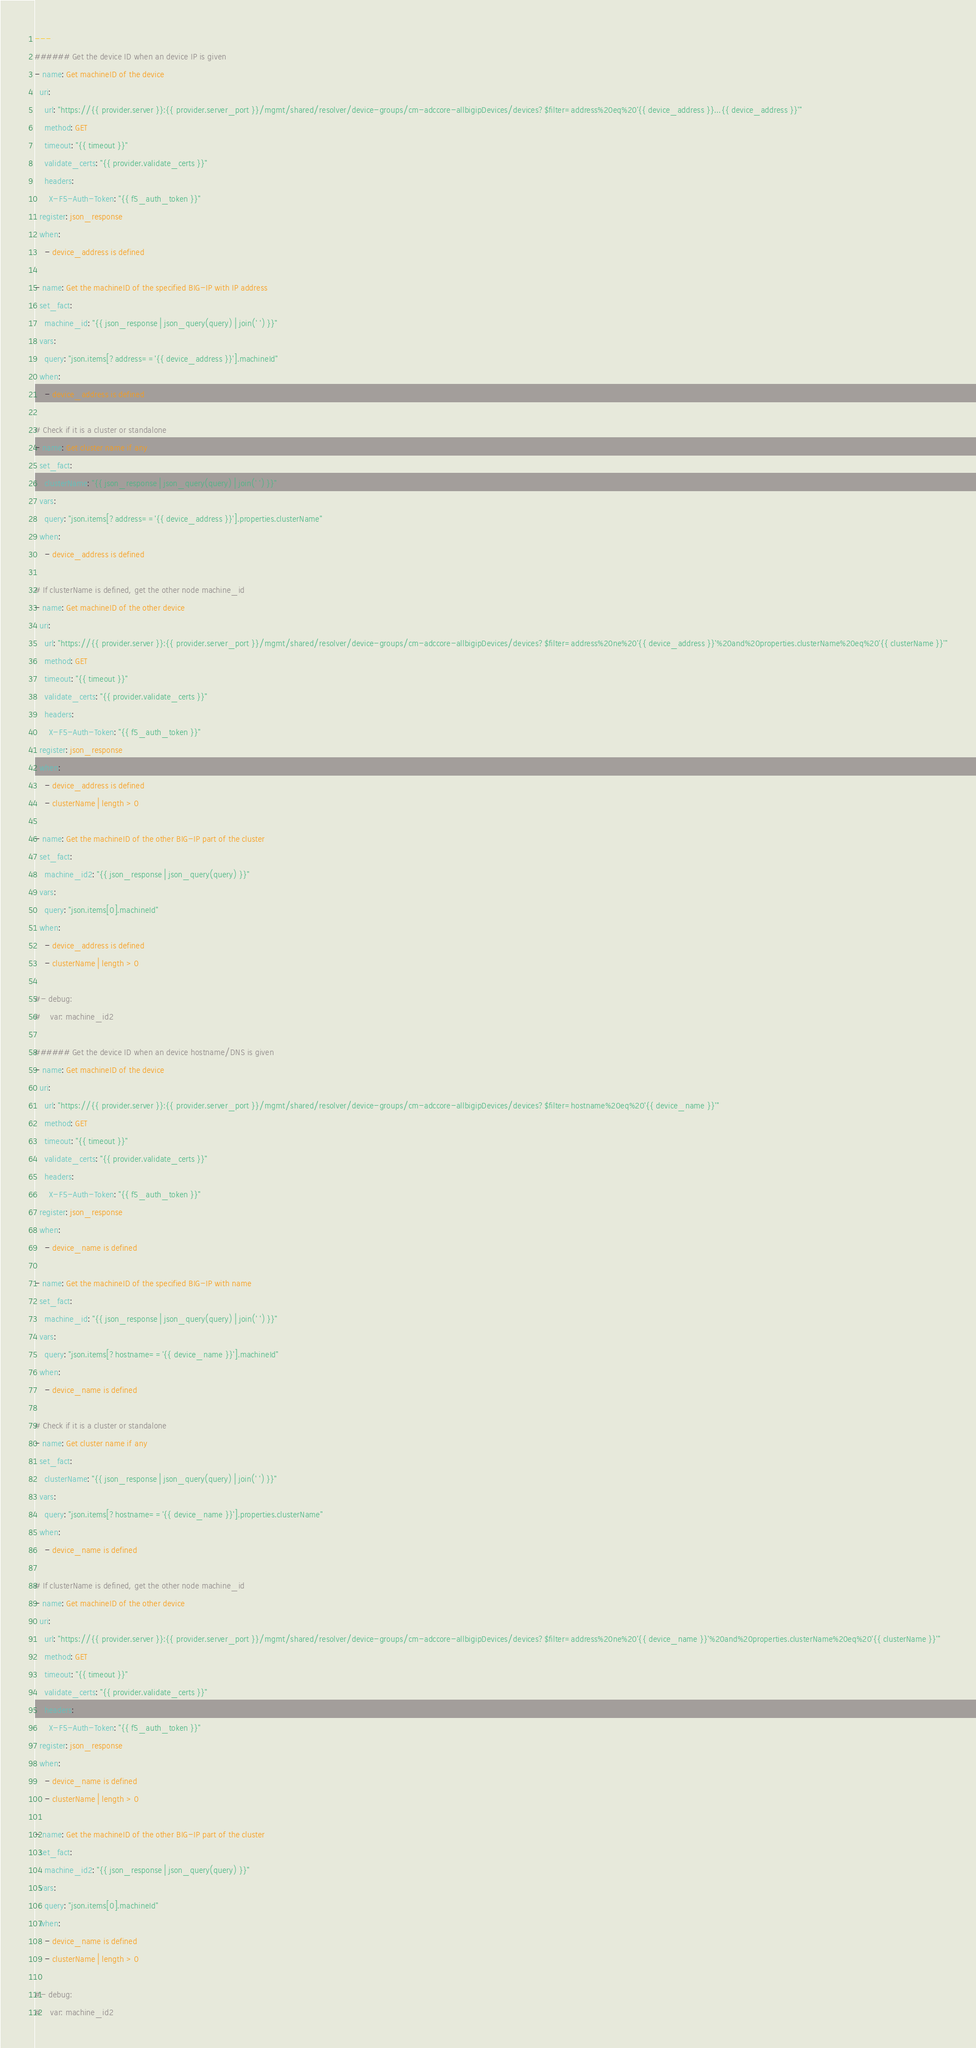<code> <loc_0><loc_0><loc_500><loc_500><_YAML_>---
###### Get the device ID when an device IP is given
- name: Get machineID of the device
  uri:
    url: "https://{{ provider.server }}:{{ provider.server_port }}/mgmt/shared/resolver/device-groups/cm-adccore-allbigipDevices/devices?$filter=address%20eq%20'{{ device_address }}...{{ device_address }}'"
    method: GET
    timeout: "{{ timeout }}"
    validate_certs: "{{ provider.validate_certs }}"
    headers:
      X-F5-Auth-Token: "{{ f5_auth_token }}"
  register: json_response
  when: 
    - device_address is defined

- name: Get the machineID of the specified BIG-IP with IP address
  set_fact:
    machine_id: "{{ json_response | json_query(query) | join(' ') }}"
  vars: 
    query: "json.items[?address=='{{ device_address }}'].machineId"
  when: 
    - device_address is defined

# Check if it is a cluster or standalone
- name: Get cluster name if any
  set_fact:
    clusterName: "{{ json_response | json_query(query) | join(' ') }}"
  vars: 
    query: "json.items[?address=='{{ device_address }}'].properties.clusterName"
  when: 
    - device_address is defined

# If clusterName is defined, get the other node machine_id
- name: Get machineID of the other device
  uri:
    url: "https://{{ provider.server }}:{{ provider.server_port }}/mgmt/shared/resolver/device-groups/cm-adccore-allbigipDevices/devices?$filter=address%20ne%20'{{ device_address }}'%20and%20properties.clusterName%20eq%20'{{ clusterName }}'"
    method: GET
    timeout: "{{ timeout }}"
    validate_certs: "{{ provider.validate_certs }}"
    headers:
      X-F5-Auth-Token: "{{ f5_auth_token }}"
  register: json_response
  when: 
    - device_address is defined
    - clusterName | length > 0
    
- name: Get the machineID of the other BIG-IP part of the cluster
  set_fact:
    machine_id2: "{{ json_response | json_query(query) }}"
  vars: 
    query: "json.items[0].machineId"
  when: 
    - device_address is defined
    - clusterName | length > 0
  
#- debug:
#    var: machine_id2

###### Get the device ID when an device hostname/DNS is given
- name: Get machineID of the device
  uri:
    url: "https://{{ provider.server }}:{{ provider.server_port }}/mgmt/shared/resolver/device-groups/cm-adccore-allbigipDevices/devices?$filter=hostname%20eq%20'{{ device_name }}'"
    method: GET
    timeout: "{{ timeout }}"
    validate_certs: "{{ provider.validate_certs }}"
    headers:
      X-F5-Auth-Token: "{{ f5_auth_token }}"
  register: json_response
  when: 
    - device_name is defined

- name: Get the machineID of the specified BIG-IP with name
  set_fact:
    machine_id: "{{ json_response | json_query(query) | join(' ') }}"
  vars: 
    query: "json.items[?hostname=='{{ device_name }}'].machineId"
  when: 
    - device_name is defined

# Check if it is a cluster or standalone
- name: Get cluster name if any
  set_fact:
    clusterName: "{{ json_response | json_query(query) | join(' ') }}"
  vars: 
    query: "json.items[?hostname=='{{ device_name }}'].properties.clusterName"
  when: 
    - device_name is defined

# If clusterName is defined, get the other node machine_id
- name: Get machineID of the other device
  uri:
    url: "https://{{ provider.server }}:{{ provider.server_port }}/mgmt/shared/resolver/device-groups/cm-adccore-allbigipDevices/devices?$filter=address%20ne%20'{{ device_name }}'%20and%20properties.clusterName%20eq%20'{{ clusterName }}'"
    method: GET
    timeout: "{{ timeout }}"
    validate_certs: "{{ provider.validate_certs }}"
    headers:
      X-F5-Auth-Token: "{{ f5_auth_token }}"
  register: json_response
  when: 
    - device_name is defined
    - clusterName | length > 0
    
- name: Get the machineID of the other BIG-IP part of the cluster
  set_fact:
    machine_id2: "{{ json_response | json_query(query) }}"
  vars: 
    query: "json.items[0].machineId"
  when: 
    - device_name is defined
    - clusterName | length > 0
  
#- debug:
#    var: machine_id2</code> 